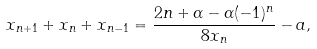Convert formula to latex. <formula><loc_0><loc_0><loc_500><loc_500>x _ { n + 1 } + x _ { n } + x _ { n - 1 } = \frac { 2 n + \alpha - \alpha ( - 1 ) ^ { n } } { 8 x _ { n } } - a ,</formula> 